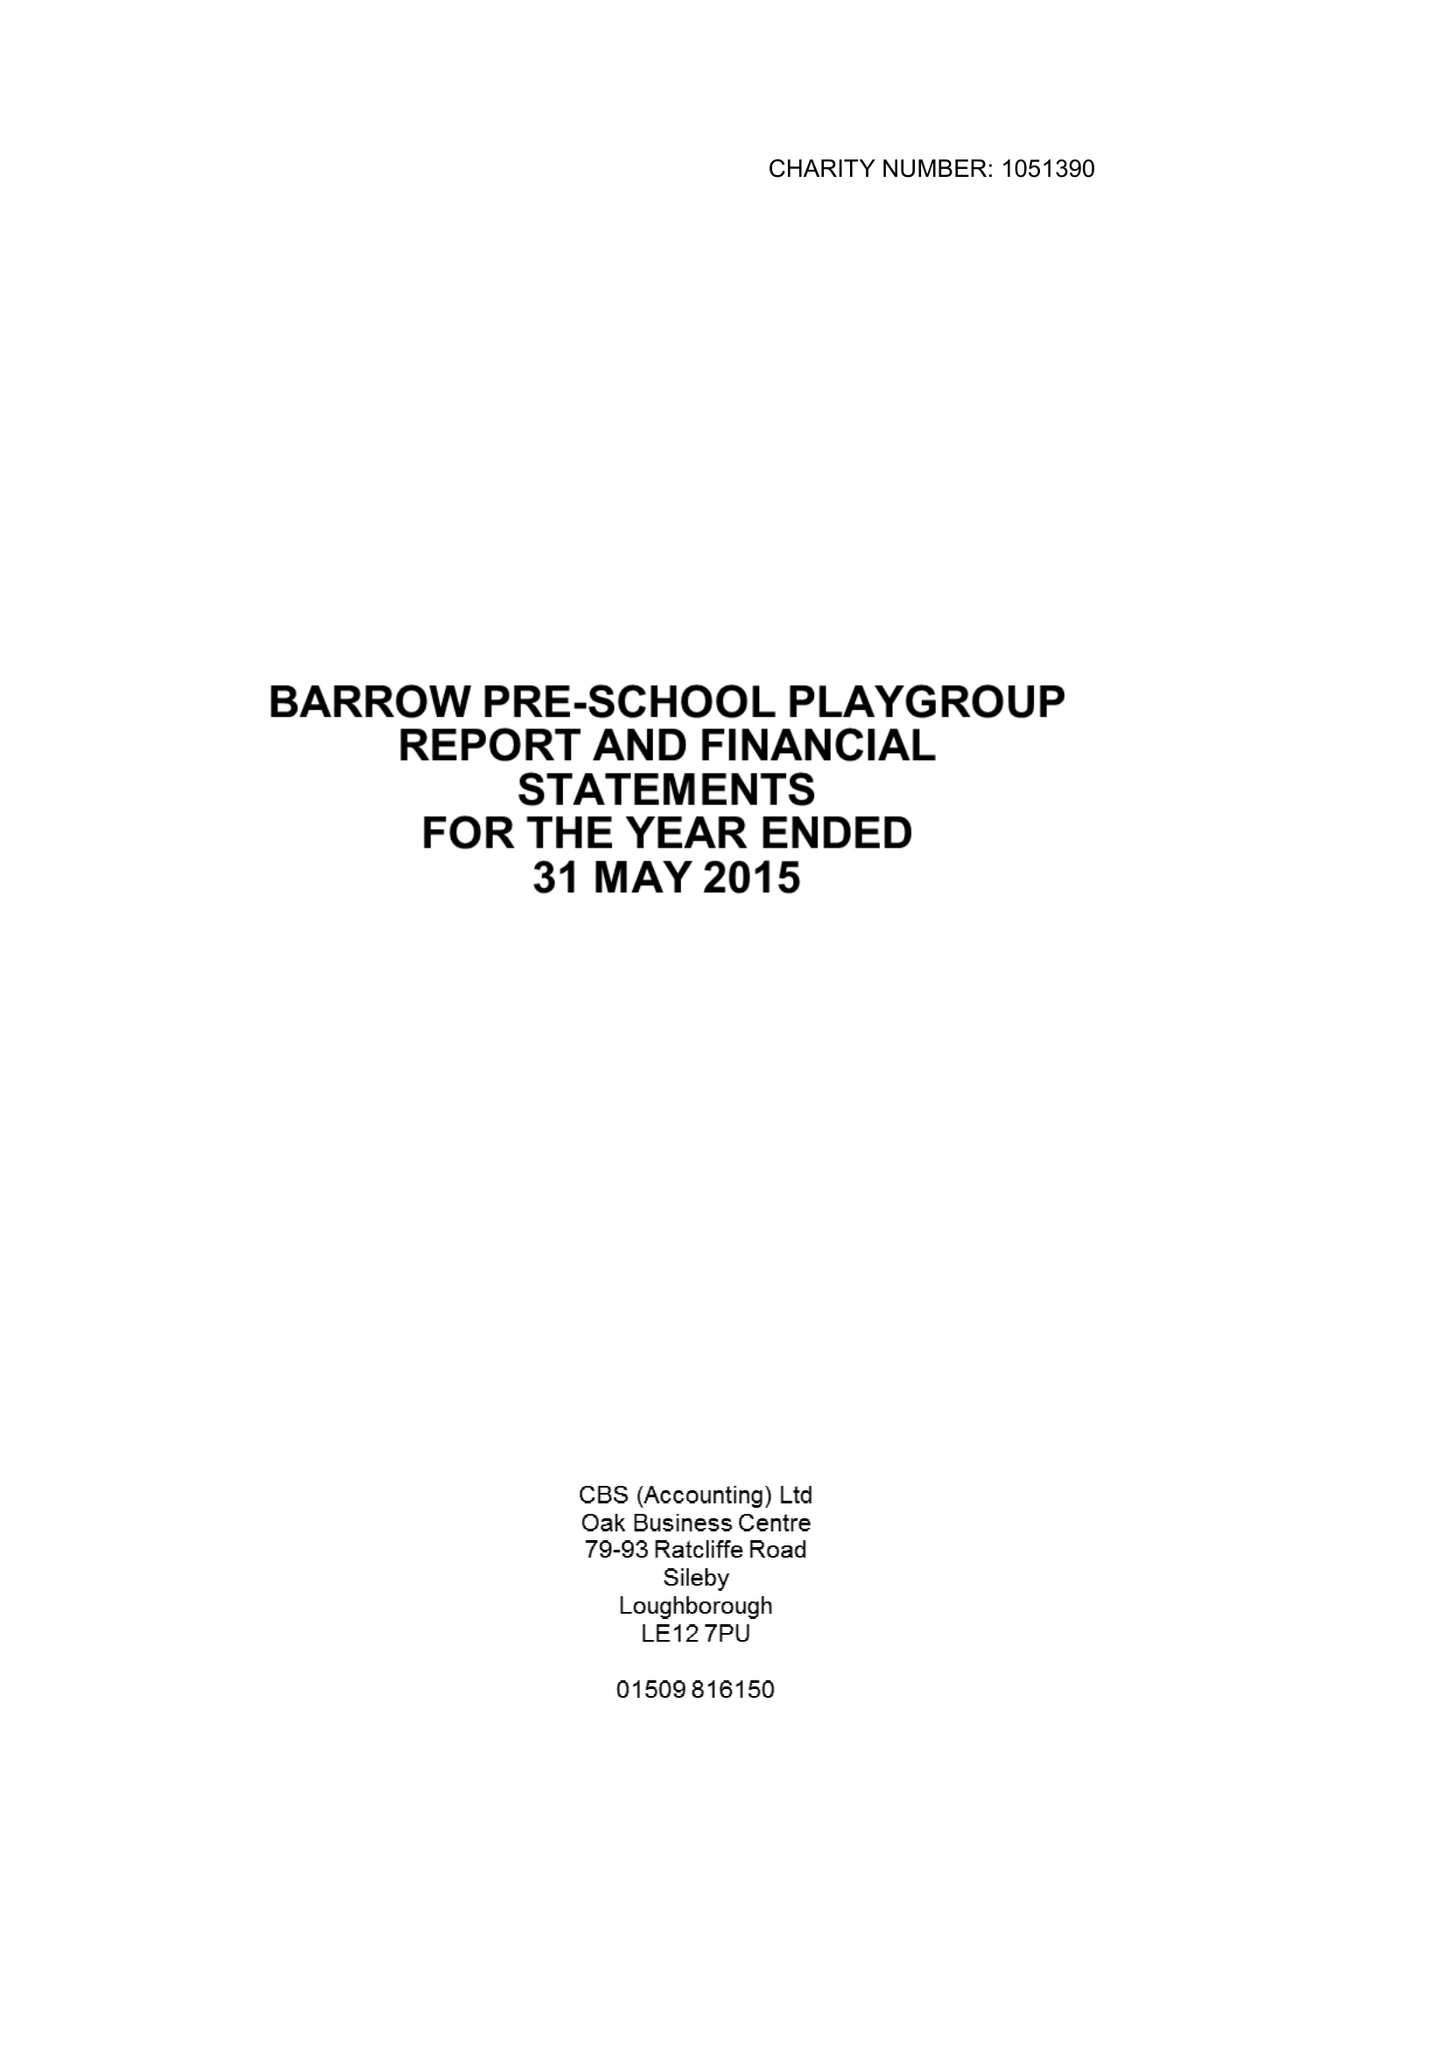What is the value for the report_date?
Answer the question using a single word or phrase. 2015-05-31 